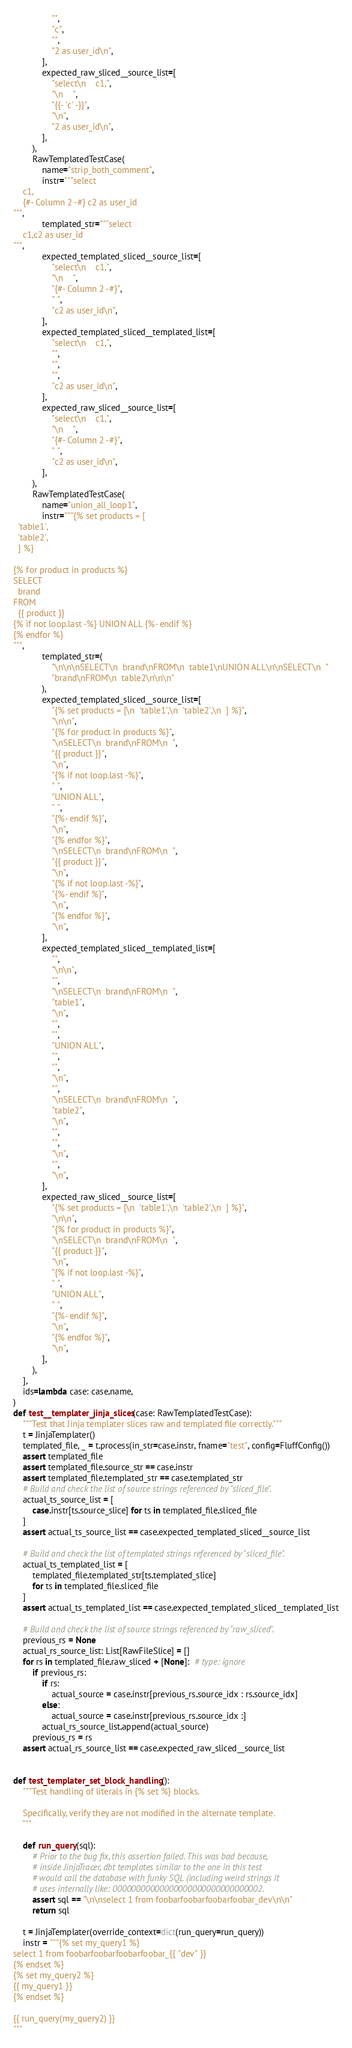Convert code to text. <code><loc_0><loc_0><loc_500><loc_500><_Python_>                "",
                "c",
                "",
                "2 as user_id\n",
            ],
            expected_raw_sliced__source_list=[
                "select\n    c1,",
                "\n    ",
                "{{- 'c' -}}",
                "\n",
                "2 as user_id\n",
            ],
        ),
        RawTemplatedTestCase(
            name="strip_both_comment",
            instr="""select
    c1,
    {#- Column 2 -#} c2 as user_id
""",
            templated_str="""select
    c1,c2 as user_id
""",
            expected_templated_sliced__source_list=[
                "select\n    c1,",
                "\n    ",
                "{#- Column 2 -#}",
                " ",
                "c2 as user_id\n",
            ],
            expected_templated_sliced__templated_list=[
                "select\n    c1,",
                "",
                "",
                "",
                "c2 as user_id\n",
            ],
            expected_raw_sliced__source_list=[
                "select\n    c1,",
                "\n    ",
                "{#- Column 2 -#}",
                " ",
                "c2 as user_id\n",
            ],
        ),
        RawTemplatedTestCase(
            name="union_all_loop1",
            instr="""{% set products = [
  'table1',
  'table2',
  ] %}

{% for product in products %}
SELECT
  brand
FROM
  {{ product }}
{% if not loop.last -%} UNION ALL {%- endif %}
{% endfor %}
""",
            templated_str=(
                "\n\n\nSELECT\n  brand\nFROM\n  table1\nUNION ALL\n\nSELECT\n  "
                "brand\nFROM\n  table2\n\n\n"
            ),
            expected_templated_sliced__source_list=[
                "{% set products = [\n  'table1',\n  'table2',\n  ] %}",
                "\n\n",
                "{% for product in products %}",
                "\nSELECT\n  brand\nFROM\n  ",
                "{{ product }}",
                "\n",
                "{% if not loop.last -%}",
                " ",
                "UNION ALL",
                " ",
                "{%- endif %}",
                "\n",
                "{% endfor %}",
                "\nSELECT\n  brand\nFROM\n  ",
                "{{ product }}",
                "\n",
                "{% if not loop.last -%}",
                "{%- endif %}",
                "\n",
                "{% endfor %}",
                "\n",
            ],
            expected_templated_sliced__templated_list=[
                "",
                "\n\n",
                "",
                "\nSELECT\n  brand\nFROM\n  ",
                "table1",
                "\n",
                "",
                "",
                "UNION ALL",
                "",
                "",
                "\n",
                "",
                "\nSELECT\n  brand\nFROM\n  ",
                "table2",
                "\n",
                "",
                "",
                "\n",
                "",
                "\n",
            ],
            expected_raw_sliced__source_list=[
                "{% set products = [\n  'table1',\n  'table2',\n  ] %}",
                "\n\n",
                "{% for product in products %}",
                "\nSELECT\n  brand\nFROM\n  ",
                "{{ product }}",
                "\n",
                "{% if not loop.last -%}",
                " ",
                "UNION ALL",
                " ",
                "{%- endif %}",
                "\n",
                "{% endfor %}",
                "\n",
            ],
        ),
    ],
    ids=lambda case: case.name,
)
def test__templater_jinja_slices(case: RawTemplatedTestCase):
    """Test that Jinja templater slices raw and templated file correctly."""
    t = JinjaTemplater()
    templated_file, _ = t.process(in_str=case.instr, fname="test", config=FluffConfig())
    assert templated_file
    assert templated_file.source_str == case.instr
    assert templated_file.templated_str == case.templated_str
    # Build and check the list of source strings referenced by "sliced_file".
    actual_ts_source_list = [
        case.instr[ts.source_slice] for ts in templated_file.sliced_file
    ]
    assert actual_ts_source_list == case.expected_templated_sliced__source_list

    # Build and check the list of templated strings referenced by "sliced_file".
    actual_ts_templated_list = [
        templated_file.templated_str[ts.templated_slice]
        for ts in templated_file.sliced_file
    ]
    assert actual_ts_templated_list == case.expected_templated_sliced__templated_list

    # Build and check the list of source strings referenced by "raw_sliced".
    previous_rs = None
    actual_rs_source_list: List[RawFileSlice] = []
    for rs in templated_file.raw_sliced + [None]:  # type: ignore
        if previous_rs:
            if rs:
                actual_source = case.instr[previous_rs.source_idx : rs.source_idx]
            else:
                actual_source = case.instr[previous_rs.source_idx :]
            actual_rs_source_list.append(actual_source)
        previous_rs = rs
    assert actual_rs_source_list == case.expected_raw_sliced__source_list


def test_templater_set_block_handling():
    """Test handling of literals in {% set %} blocks.

    Specifically, verify they are not modified in the alternate template.
    """

    def run_query(sql):
        # Prior to the bug fix, this assertion failed. This was bad because,
        # inside JinjaTracer, dbt templates similar to the one in this test
        # would call the database with funky SQL (including weird strings it
        # uses internally like: 00000000000000000000000000000002.
        assert sql == "\n\nselect 1 from foobarfoobarfoobarfoobar_dev\n\n"
        return sql

    t = JinjaTemplater(override_context=dict(run_query=run_query))
    instr = """{% set my_query1 %}
select 1 from foobarfoobarfoobarfoobar_{{ "dev" }}
{% endset %}
{% set my_query2 %}
{{ my_query1 }}
{% endset %}

{{ run_query(my_query2) }}
"""</code> 